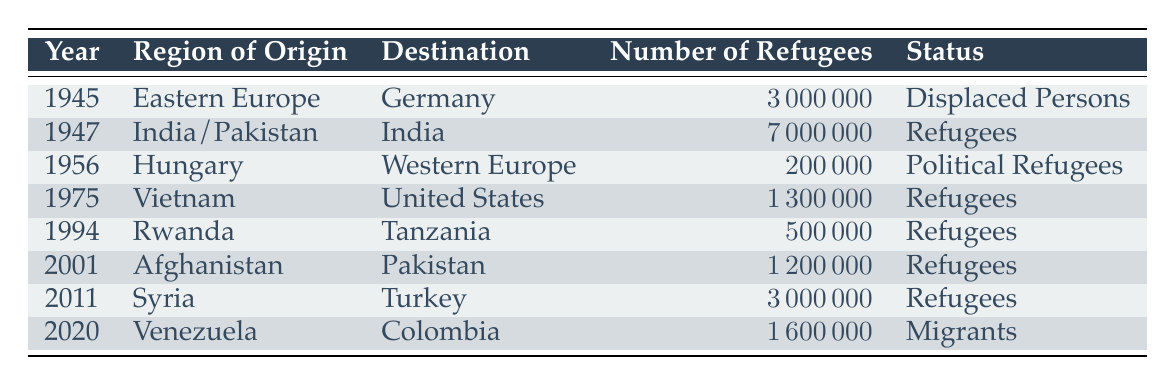What was the highest number of refugees recorded in the table? The highest number of refugees can be found by reviewing the "Number of Refugees" column. Upon inspection, 7000000 in the year 1947 from India/Pakistan to India is the largest figure present in the dataset.
Answer: 7000000 How many refugees migrated from Afghanistan to Pakistan in 2001? The table specifies that the number of refugees from Afghanistan to Pakistan in 2001 is 1200000, which can be found directly in the "Number of Refugees" column under the corresponding year and origin.
Answer: 1200000 Which year had the lowest number of refugees and what was that number? By reviewing each entry in the "Number of Refugees" column, the smallest figure is identified as 200000 in the year 1956 from Hungary to Western Europe. This was discovered after comparing all total values of refugees listed.
Answer: 200000 Are there more refugees recorded from Eastern Europe than from Syria? Comparing the figures, Eastern Europe had 3000000 refugees in 1945, while Syria had 3000000 refugees in 2011. Since both figures are equal, the answer is no, one is not more than the other; they are the same.
Answer: No What is the total number of refugees registered from India/Pakistan and Venezuela combined? To find the total, we add the number of refugees from India/Pakistan in 1947 (7000000) and from Venezuela in 2020 (1600000). The calculation is 7000000 + 1600000 = 8600000. Therefore, the combined total of both migrations leads to this figure.
Answer: 8600000 How many years in the table record a status of "Refugees"? By reviewing the table, we identify and count the rows with the status "Refugees". The occurrences are in the years 1947, 1975, 1994, 2001, 2011, and the total comes to 5 records in that category.
Answer: 5 Which region had refugees recorded in the table with a status of "Political Refugees"? Looking through the status column, the only entry designated as "Political Refugees" is from Hungary in the year 1956, identifying that this is the sole region that matches this specific status within the dataset.
Answer: Hungary What percentage of the total recorded refugees from the table comes from the year 2011? First, we need the number of refugees from 2011 (3000000) and the total refugees across the whole table, which is 12000000. The percentage is calculated as (3000000 / 12000000) * 100 = 25%.
Answer: 25% 